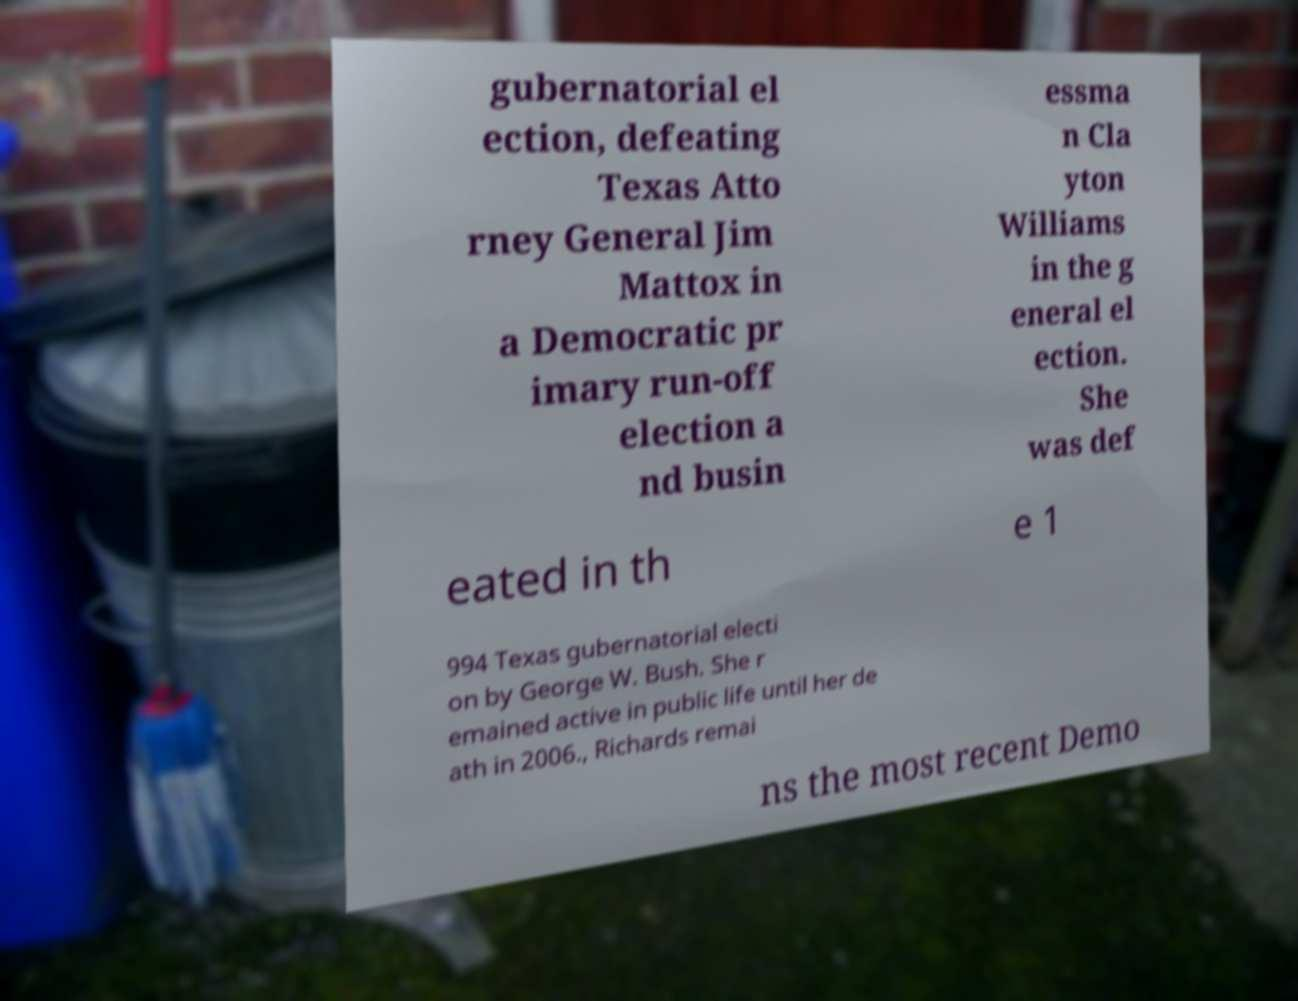Could you extract and type out the text from this image? gubernatorial el ection, defeating Texas Atto rney General Jim Mattox in a Democratic pr imary run-off election a nd busin essma n Cla yton Williams in the g eneral el ection. She was def eated in th e 1 994 Texas gubernatorial electi on by George W. Bush. She r emained active in public life until her de ath in 2006., Richards remai ns the most recent Demo 